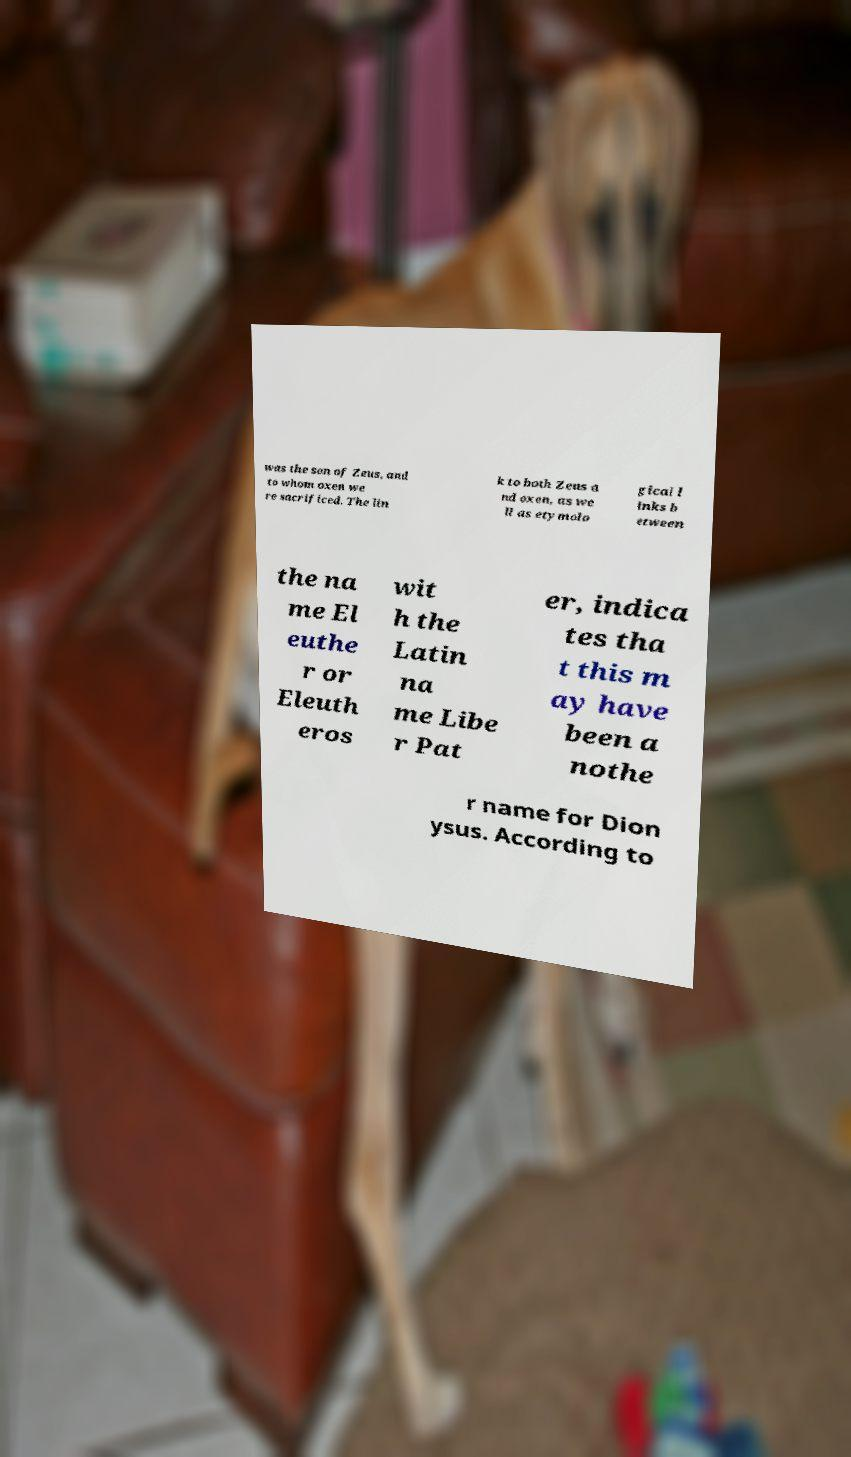There's text embedded in this image that I need extracted. Can you transcribe it verbatim? was the son of Zeus, and to whom oxen we re sacrificed. The lin k to both Zeus a nd oxen, as we ll as etymolo gical l inks b etween the na me El euthe r or Eleuth eros wit h the Latin na me Libe r Pat er, indica tes tha t this m ay have been a nothe r name for Dion ysus. According to 